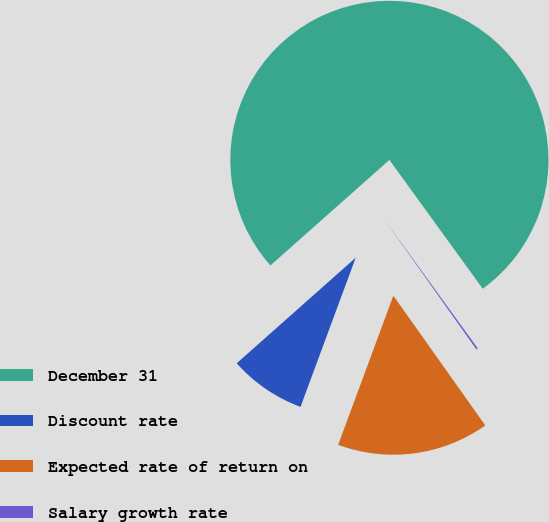<chart> <loc_0><loc_0><loc_500><loc_500><pie_chart><fcel>December 31<fcel>Discount rate<fcel>Expected rate of return on<fcel>Salary growth rate<nl><fcel>76.57%<fcel>7.81%<fcel>15.45%<fcel>0.17%<nl></chart> 